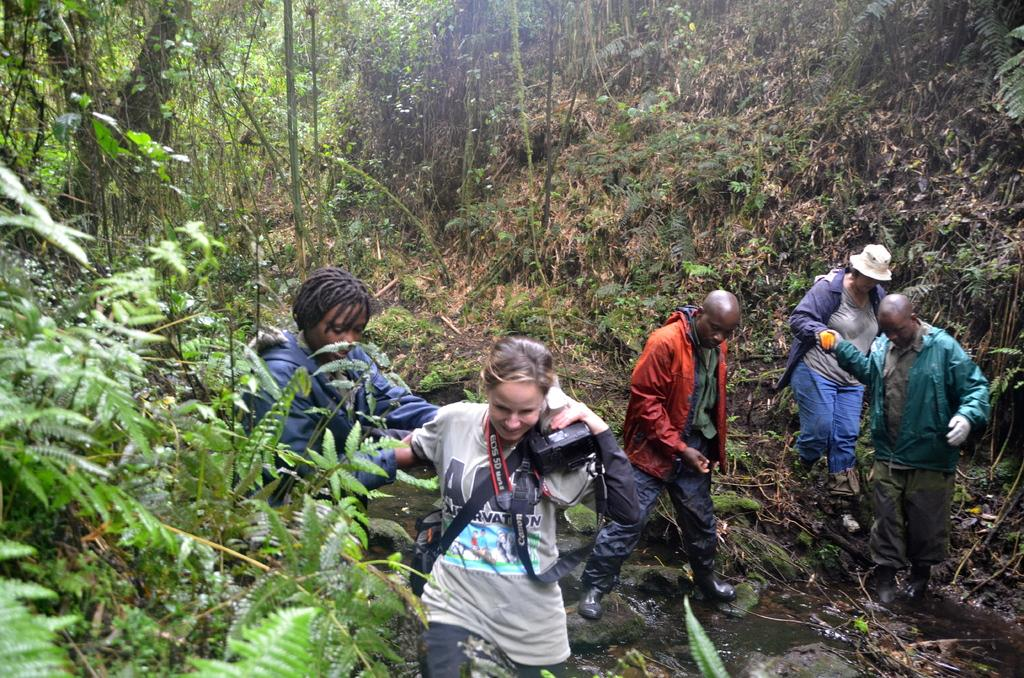How many people are in the image? There is a group of people in the image. What are the people doing in the image? The people are walking in a forest. Can you describe the person holding an object in the image? One of the people is holding a camera. What type of natural environment is visible in the image? There are trees, plants, and grass in the image. What type of baseball equipment can be seen in the image? There is no baseball equipment present in the image. Can you tell me how many chess pieces are visible on the ground in the image? There are no chess pieces visible in the image. 